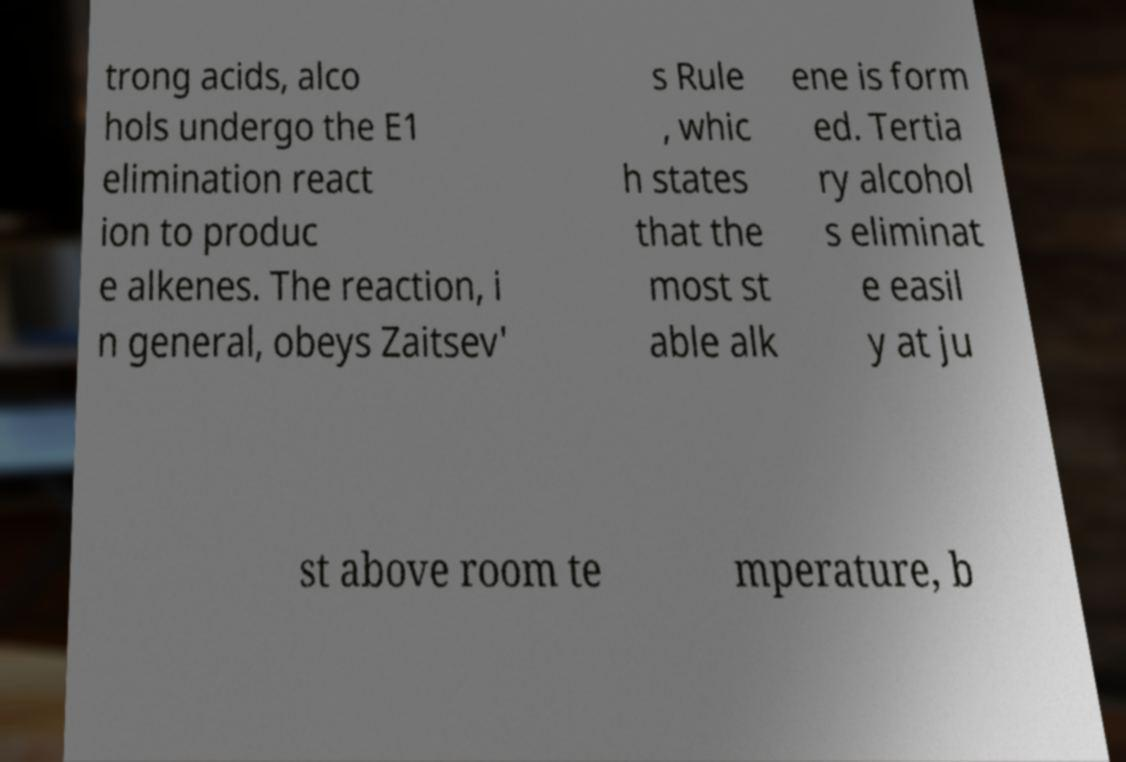Can you read and provide the text displayed in the image?This photo seems to have some interesting text. Can you extract and type it out for me? trong acids, alco hols undergo the E1 elimination react ion to produc e alkenes. The reaction, i n general, obeys Zaitsev' s Rule , whic h states that the most st able alk ene is form ed. Tertia ry alcohol s eliminat e easil y at ju st above room te mperature, b 